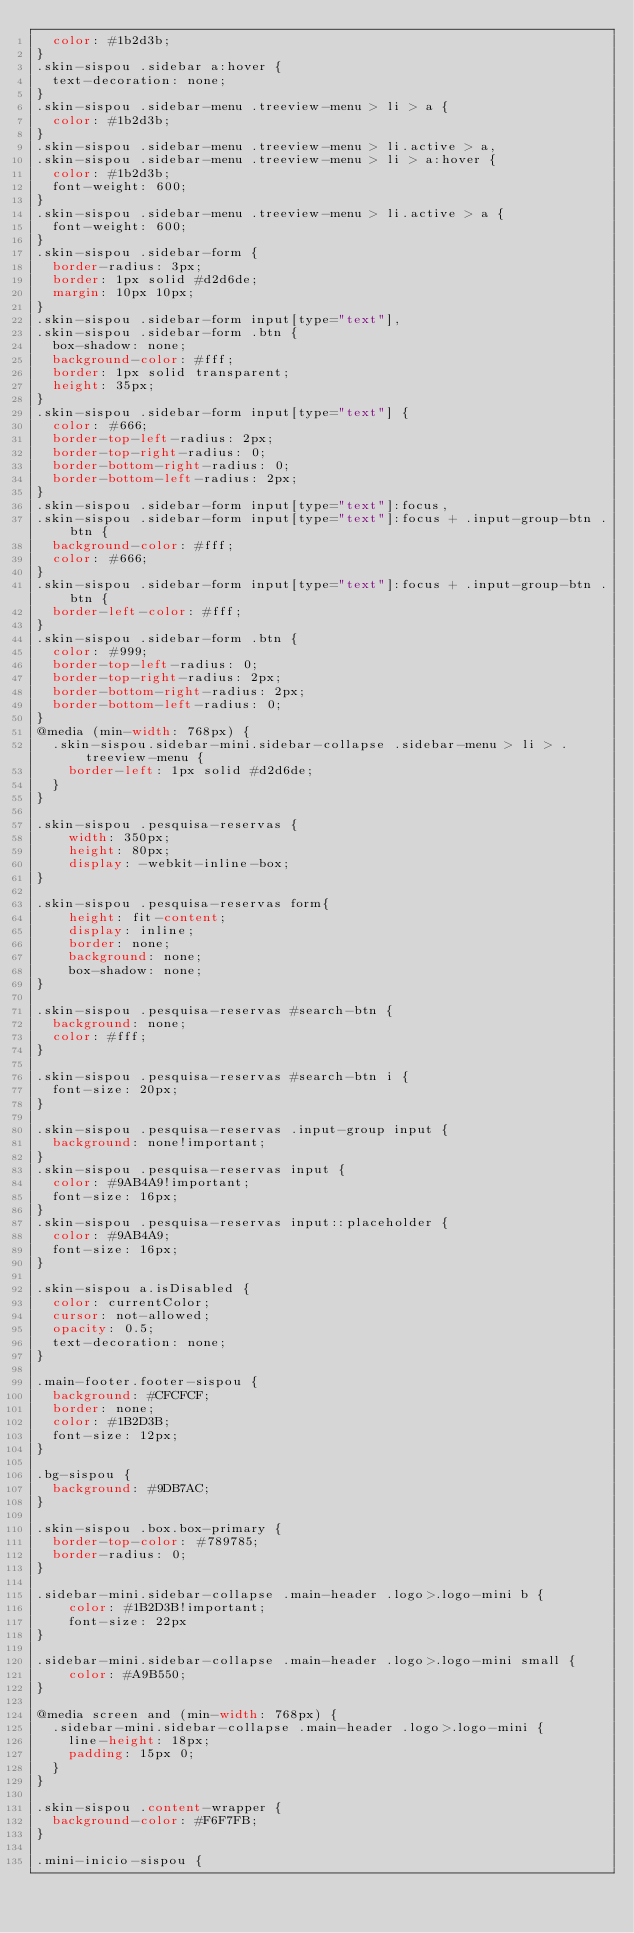Convert code to text. <code><loc_0><loc_0><loc_500><loc_500><_CSS_>  color: #1b2d3b;
}
.skin-sispou .sidebar a:hover {
  text-decoration: none;
}
.skin-sispou .sidebar-menu .treeview-menu > li > a {
  color: #1b2d3b;
}
.skin-sispou .sidebar-menu .treeview-menu > li.active > a,
.skin-sispou .sidebar-menu .treeview-menu > li > a:hover {
  color: #1b2d3b;
  font-weight: 600;
}
.skin-sispou .sidebar-menu .treeview-menu > li.active > a {
  font-weight: 600;
}
.skin-sispou .sidebar-form {
  border-radius: 3px;
  border: 1px solid #d2d6de;
  margin: 10px 10px;
}
.skin-sispou .sidebar-form input[type="text"],
.skin-sispou .sidebar-form .btn {
  box-shadow: none;
  background-color: #fff;
  border: 1px solid transparent;
  height: 35px;
}
.skin-sispou .sidebar-form input[type="text"] {
  color: #666;
  border-top-left-radius: 2px;
  border-top-right-radius: 0;
  border-bottom-right-radius: 0;
  border-bottom-left-radius: 2px;
}
.skin-sispou .sidebar-form input[type="text"]:focus,
.skin-sispou .sidebar-form input[type="text"]:focus + .input-group-btn .btn {
  background-color: #fff;
  color: #666;
}
.skin-sispou .sidebar-form input[type="text"]:focus + .input-group-btn .btn {
  border-left-color: #fff;
}
.skin-sispou .sidebar-form .btn {
  color: #999;
  border-top-left-radius: 0;
  border-top-right-radius: 2px;
  border-bottom-right-radius: 2px;
  border-bottom-left-radius: 0;
}
@media (min-width: 768px) {
  .skin-sispou.sidebar-mini.sidebar-collapse .sidebar-menu > li > .treeview-menu {
    border-left: 1px solid #d2d6de;
  }
}

.skin-sispou .pesquisa-reservas {
    width: 350px;
    height: 80px;
    display: -webkit-inline-box;
}

.skin-sispou .pesquisa-reservas form{
    height: fit-content;
    display: inline;
    border: none;
    background: none;
    box-shadow: none;
}

.skin-sispou .pesquisa-reservas #search-btn {
  background: none;
  color: #fff;
}

.skin-sispou .pesquisa-reservas #search-btn i {
  font-size: 20px;
}

.skin-sispou .pesquisa-reservas .input-group input {
  background: none!important;
}
.skin-sispou .pesquisa-reservas input {
  color: #9AB4A9!important;
  font-size: 16px;
}
.skin-sispou .pesquisa-reservas input::placeholder {
  color: #9AB4A9;
  font-size: 16px;
}

.skin-sispou a.isDisabled {
  color: currentColor;
  cursor: not-allowed;
  opacity: 0.5;
  text-decoration: none;
}

.main-footer.footer-sispou {
  background: #CFCFCF;
  border: none;
  color: #1B2D3B;
  font-size: 12px;
}

.bg-sispou {
  background: #9DB7AC;
}

.skin-sispou .box.box-primary {
  border-top-color: #789785;
  border-radius: 0;
}

.sidebar-mini.sidebar-collapse .main-header .logo>.logo-mini b {
    color: #1B2D3B!important;
    font-size: 22px
}

.sidebar-mini.sidebar-collapse .main-header .logo>.logo-mini small {
    color: #A9B550;
}

@media screen and (min-width: 768px) {
  .sidebar-mini.sidebar-collapse .main-header .logo>.logo-mini {
    line-height: 18px;
    padding: 15px 0;
  }
}

.skin-sispou .content-wrapper {
  background-color: #F6F7FB;
}

.mini-inicio-sispou {</code> 